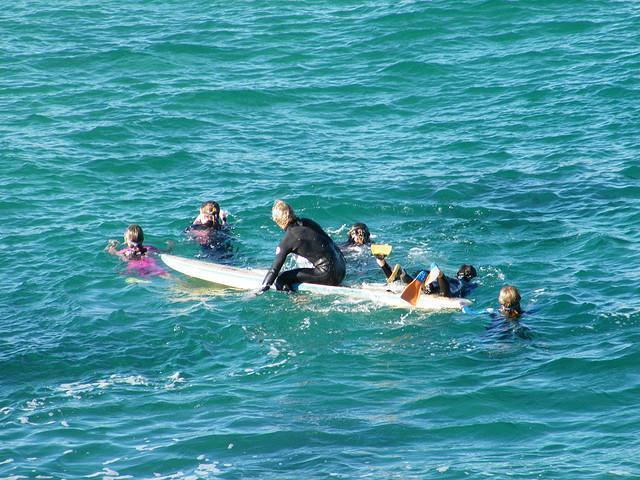What is the orange object on the woman's foot?
From the following four choices, select the correct answer to address the question.
Options: Crocs, water bottle, swimfins, socks. Swimfins. 